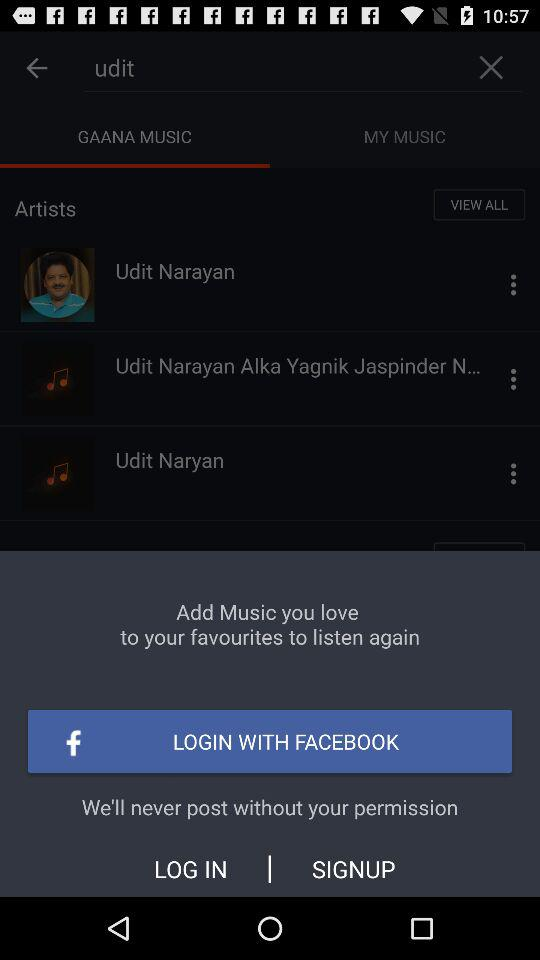What is the available option for logging in? The available option for logging in is "FACEBOOK". 